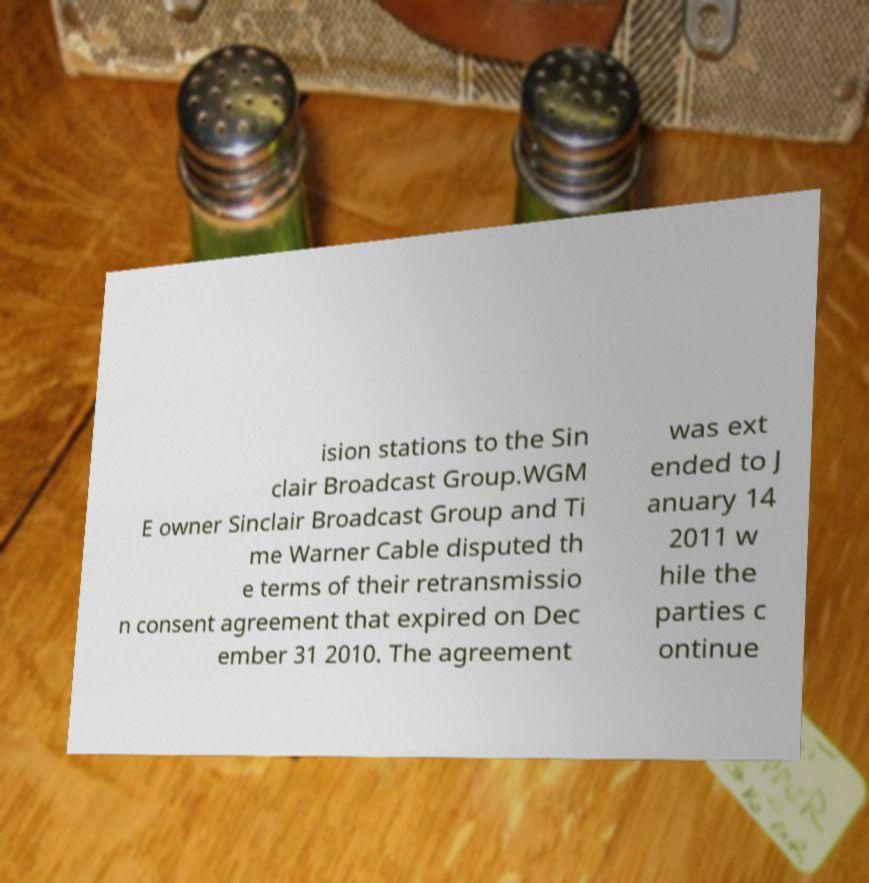Please identify and transcribe the text found in this image. ision stations to the Sin clair Broadcast Group.WGM E owner Sinclair Broadcast Group and Ti me Warner Cable disputed th e terms of their retransmissio n consent agreement that expired on Dec ember 31 2010. The agreement was ext ended to J anuary 14 2011 w hile the parties c ontinue 